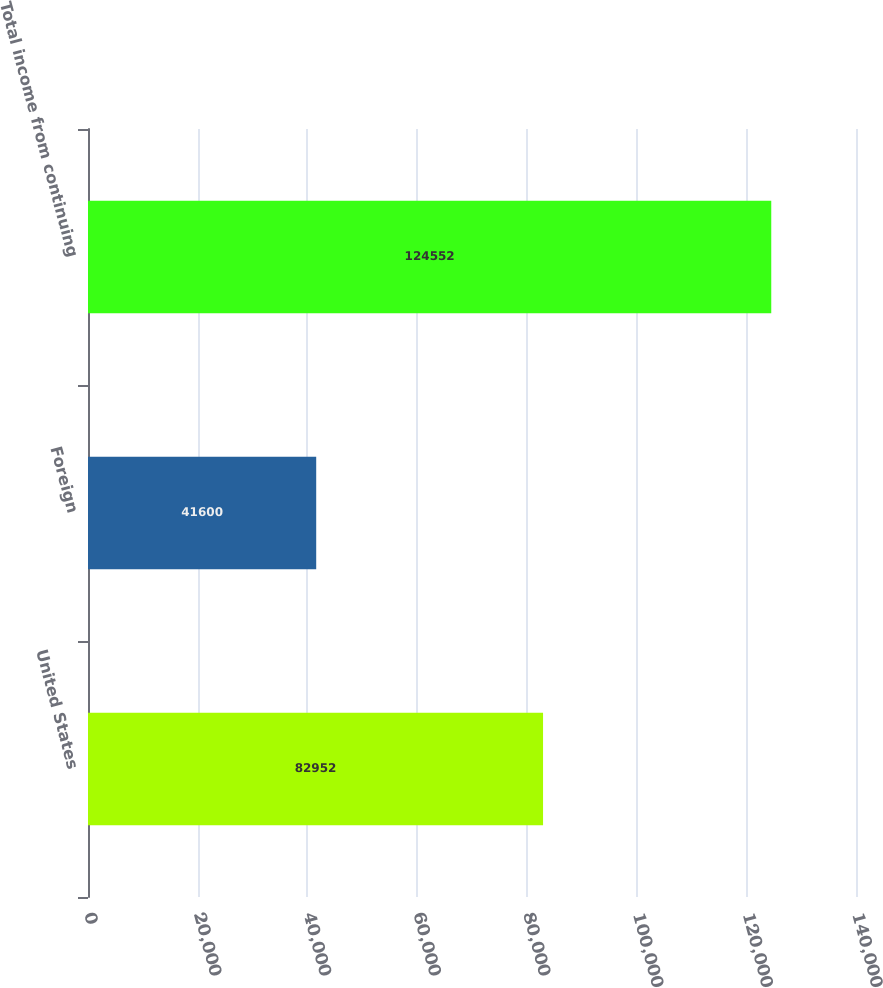<chart> <loc_0><loc_0><loc_500><loc_500><bar_chart><fcel>United States<fcel>Foreign<fcel>Total income from continuing<nl><fcel>82952<fcel>41600<fcel>124552<nl></chart> 